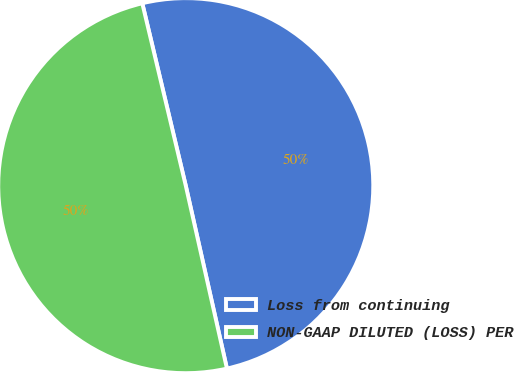Convert chart. <chart><loc_0><loc_0><loc_500><loc_500><pie_chart><fcel>Loss from continuing<fcel>NON-GAAP DILUTED (LOSS) PER<nl><fcel>50.2%<fcel>49.8%<nl></chart> 